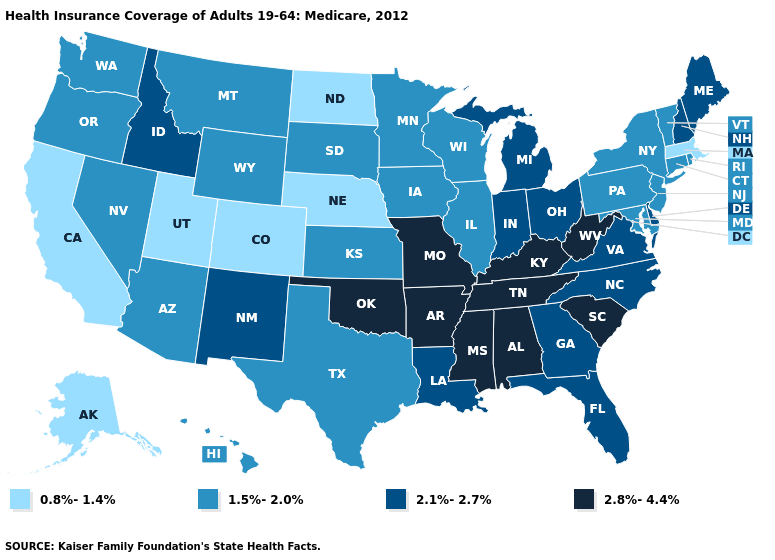What is the value of Michigan?
Keep it brief. 2.1%-2.7%. What is the highest value in the USA?
Keep it brief. 2.8%-4.4%. Name the states that have a value in the range 2.1%-2.7%?
Answer briefly. Delaware, Florida, Georgia, Idaho, Indiana, Louisiana, Maine, Michigan, New Hampshire, New Mexico, North Carolina, Ohio, Virginia. Which states have the highest value in the USA?
Write a very short answer. Alabama, Arkansas, Kentucky, Mississippi, Missouri, Oklahoma, South Carolina, Tennessee, West Virginia. What is the value of Montana?
Write a very short answer. 1.5%-2.0%. What is the lowest value in the Northeast?
Short answer required. 0.8%-1.4%. What is the value of Massachusetts?
Short answer required. 0.8%-1.4%. Does Indiana have the same value as Vermont?
Concise answer only. No. Name the states that have a value in the range 2.8%-4.4%?
Write a very short answer. Alabama, Arkansas, Kentucky, Mississippi, Missouri, Oklahoma, South Carolina, Tennessee, West Virginia. What is the value of Kansas?
Write a very short answer. 1.5%-2.0%. What is the lowest value in the Northeast?
Short answer required. 0.8%-1.4%. What is the value of Arizona?
Quick response, please. 1.5%-2.0%. What is the value of North Carolina?
Write a very short answer. 2.1%-2.7%. Among the states that border Connecticut , does Massachusetts have the highest value?
Keep it brief. No. What is the value of New Mexico?
Quick response, please. 2.1%-2.7%. 